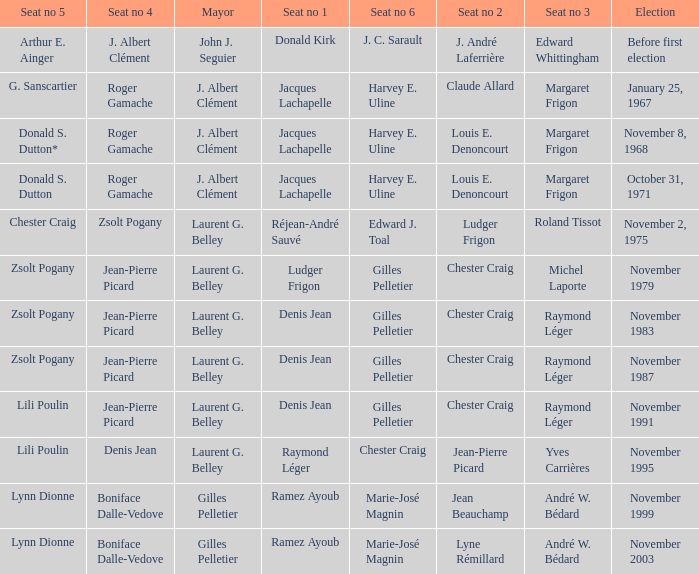Who is seat no 1 when the mayor was john j. seguier Donald Kirk. 